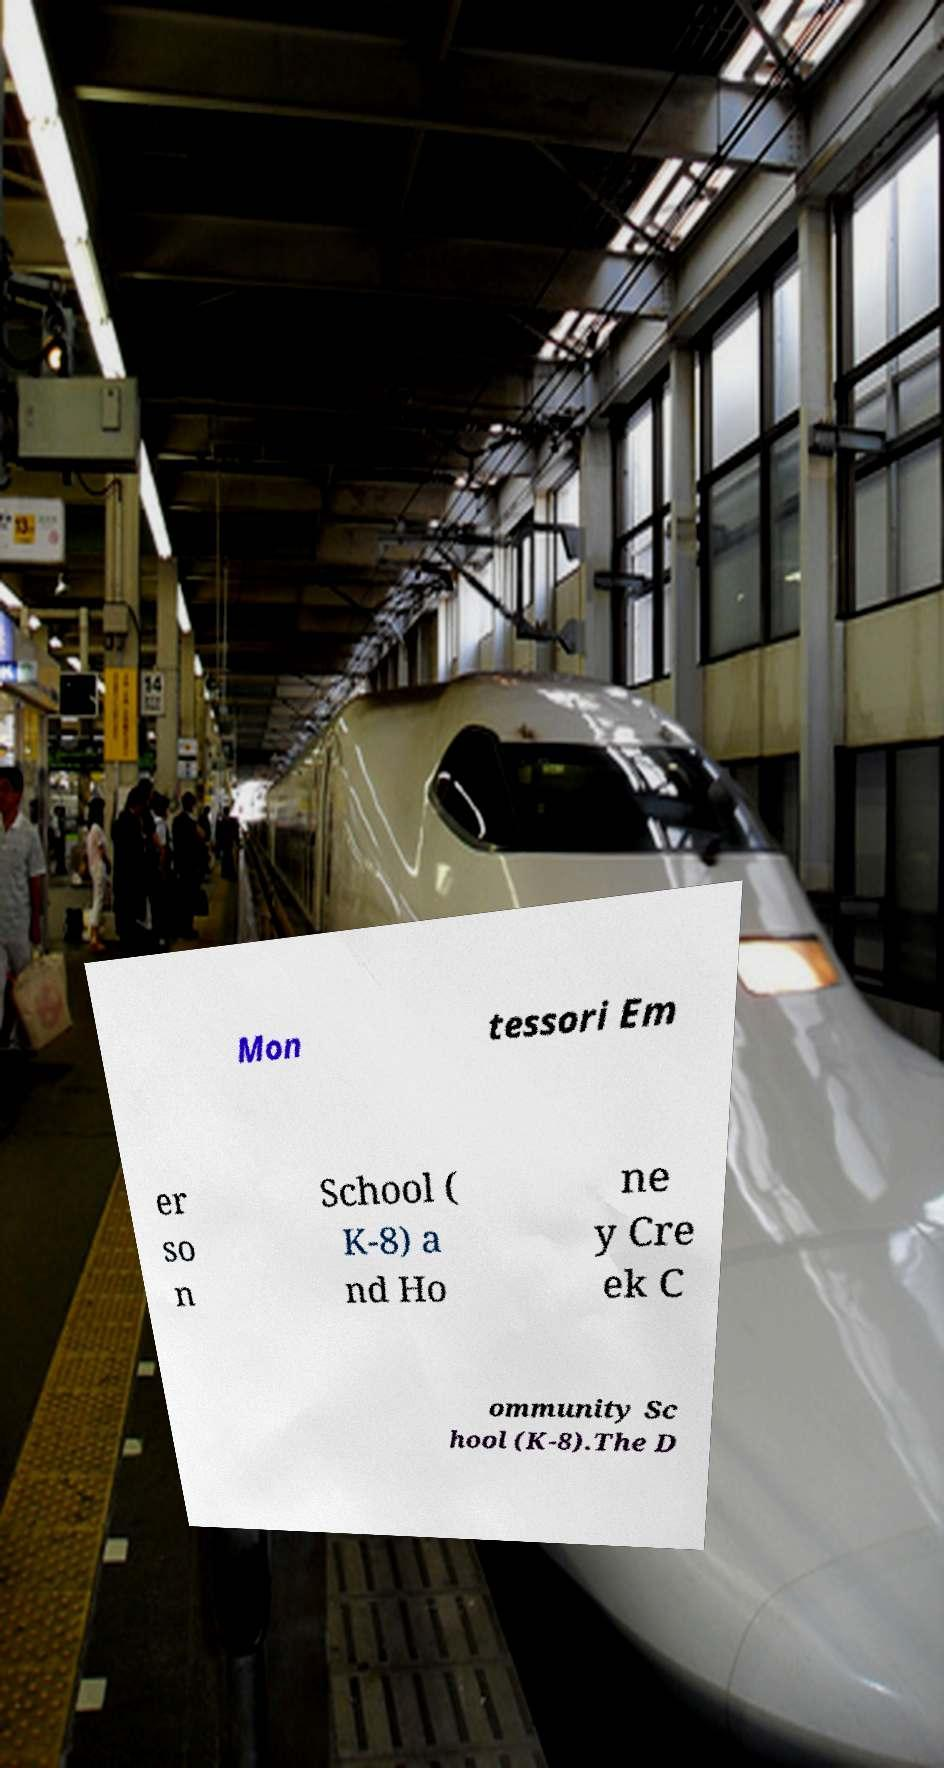There's text embedded in this image that I need extracted. Can you transcribe it verbatim? Mon tessori Em er so n School ( K-8) a nd Ho ne y Cre ek C ommunity Sc hool (K-8).The D 